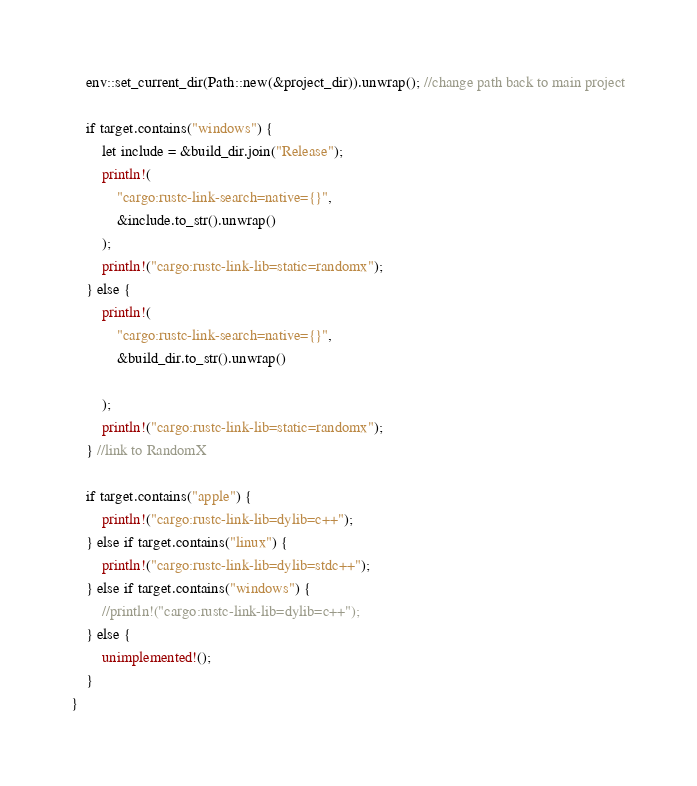Convert code to text. <code><loc_0><loc_0><loc_500><loc_500><_Rust_>
    env::set_current_dir(Path::new(&project_dir)).unwrap(); //change path back to main project

    if target.contains("windows") {
        let include = &build_dir.join("Release");
        println!(
            "cargo:rustc-link-search=native={}",
            &include.to_str().unwrap()
        );
        println!("cargo:rustc-link-lib=static=randomx");
    } else {
        println!(
            "cargo:rustc-link-search=native={}",
            &build_dir.to_str().unwrap()

        );
        println!("cargo:rustc-link-lib=static=randomx");
    } //link to RandomX

    if target.contains("apple") {
        println!("cargo:rustc-link-lib=dylib=c++");
    } else if target.contains("linux") {
        println!("cargo:rustc-link-lib=dylib=stdc++");
    } else if target.contains("windows") {
        //println!("cargo:rustc-link-lib=dylib=c++");
    } else {
        unimplemented!();
    }
}
</code> 